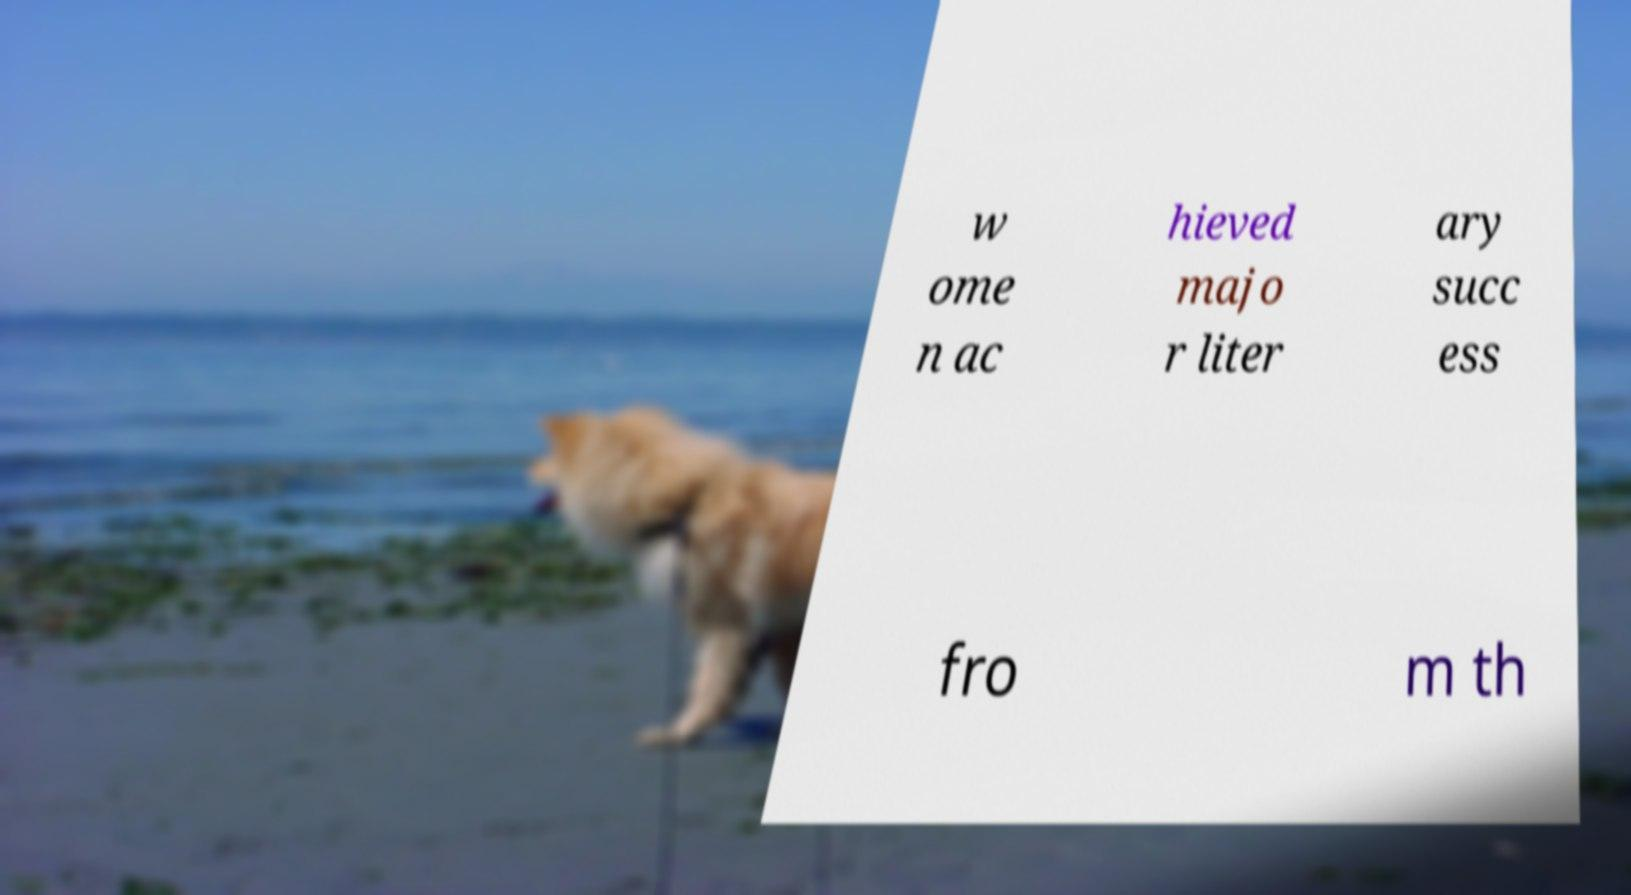For documentation purposes, I need the text within this image transcribed. Could you provide that? w ome n ac hieved majo r liter ary succ ess fro m th 